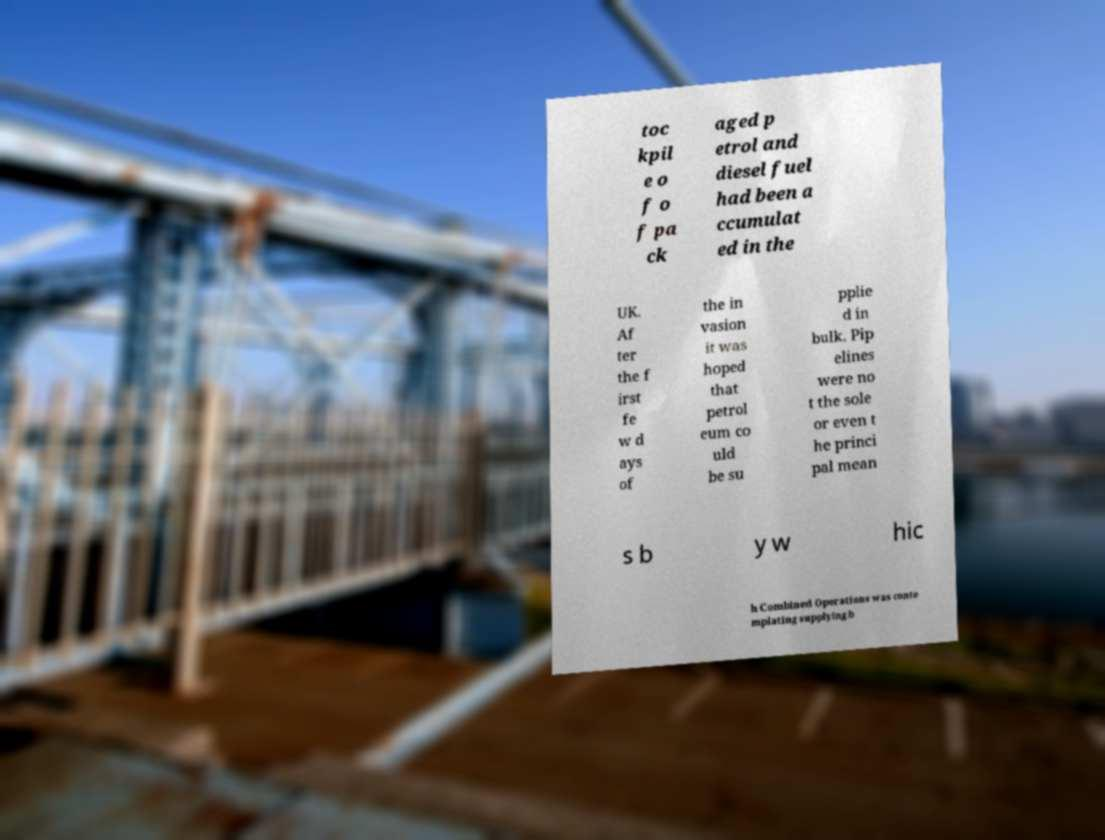Please identify and transcribe the text found in this image. toc kpil e o f o f pa ck aged p etrol and diesel fuel had been a ccumulat ed in the UK. Af ter the f irst fe w d ays of the in vasion it was hoped that petrol eum co uld be su pplie d in bulk. Pip elines were no t the sole or even t he princi pal mean s b y w hic h Combined Operations was conte mplating supplying b 